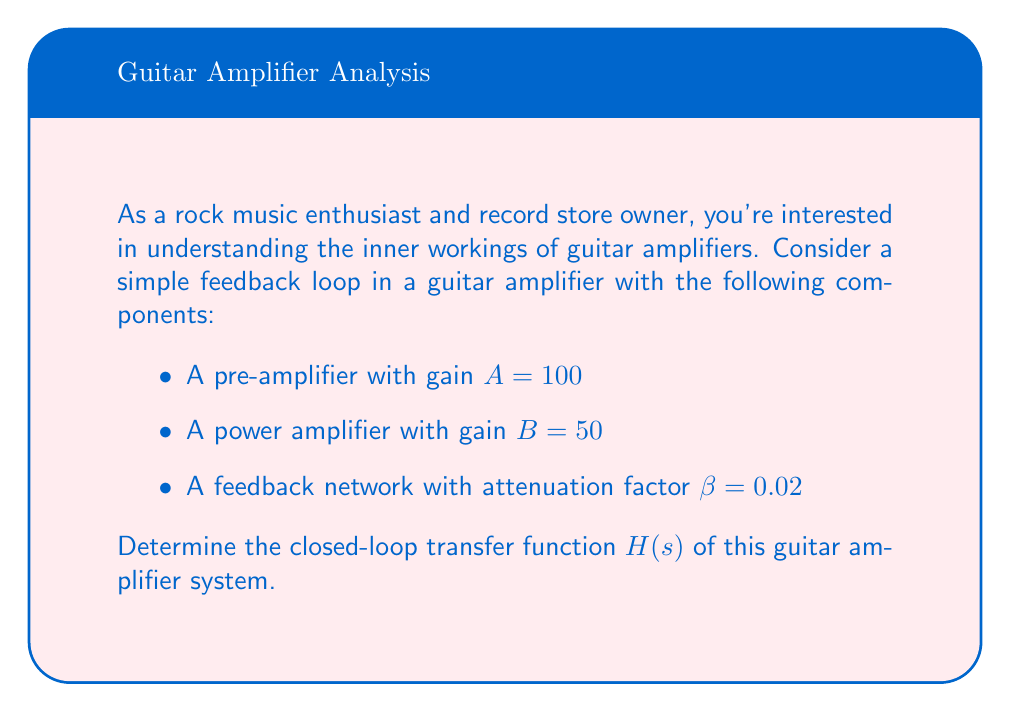Give your solution to this math problem. To determine the closed-loop transfer function of the guitar amplifier's feedback loop, we'll follow these steps:

1. Identify the components of the system:
   - Pre-amplifier gain: $A = 100$
   - Power amplifier gain: $B = 50$
   - Feedback network attenuation: $\beta = 0.02$

2. Calculate the forward path gain:
   The forward path gain is the product of the pre-amplifier and power amplifier gains.
   $$G = A \cdot B = 100 \cdot 50 = 5000$$

3. Apply the closed-loop transfer function formula:
   For a negative feedback system, the closed-loop transfer function is given by:
   $$H(s) = \frac{G}{1 + G\beta}$$

4. Substitute the values:
   $$H(s) = \frac{5000}{1 + 5000 \cdot 0.02}$$

5. Simplify:
   $$H(s) = \frac{5000}{1 + 100} = \frac{5000}{101}$$

6. Calculate the final result:
   $$H(s) \approx 49.5050$$

This closed-loop transfer function represents the overall gain of the guitar amplifier system with feedback. It's lower than the open-loop gain (5000) due to the negative feedback, which improves stability and reduces distortion - crucial factors for achieving that perfect rock sound!
Answer: $$H(s) = \frac{5000}{101} \approx 49.5050$$ 